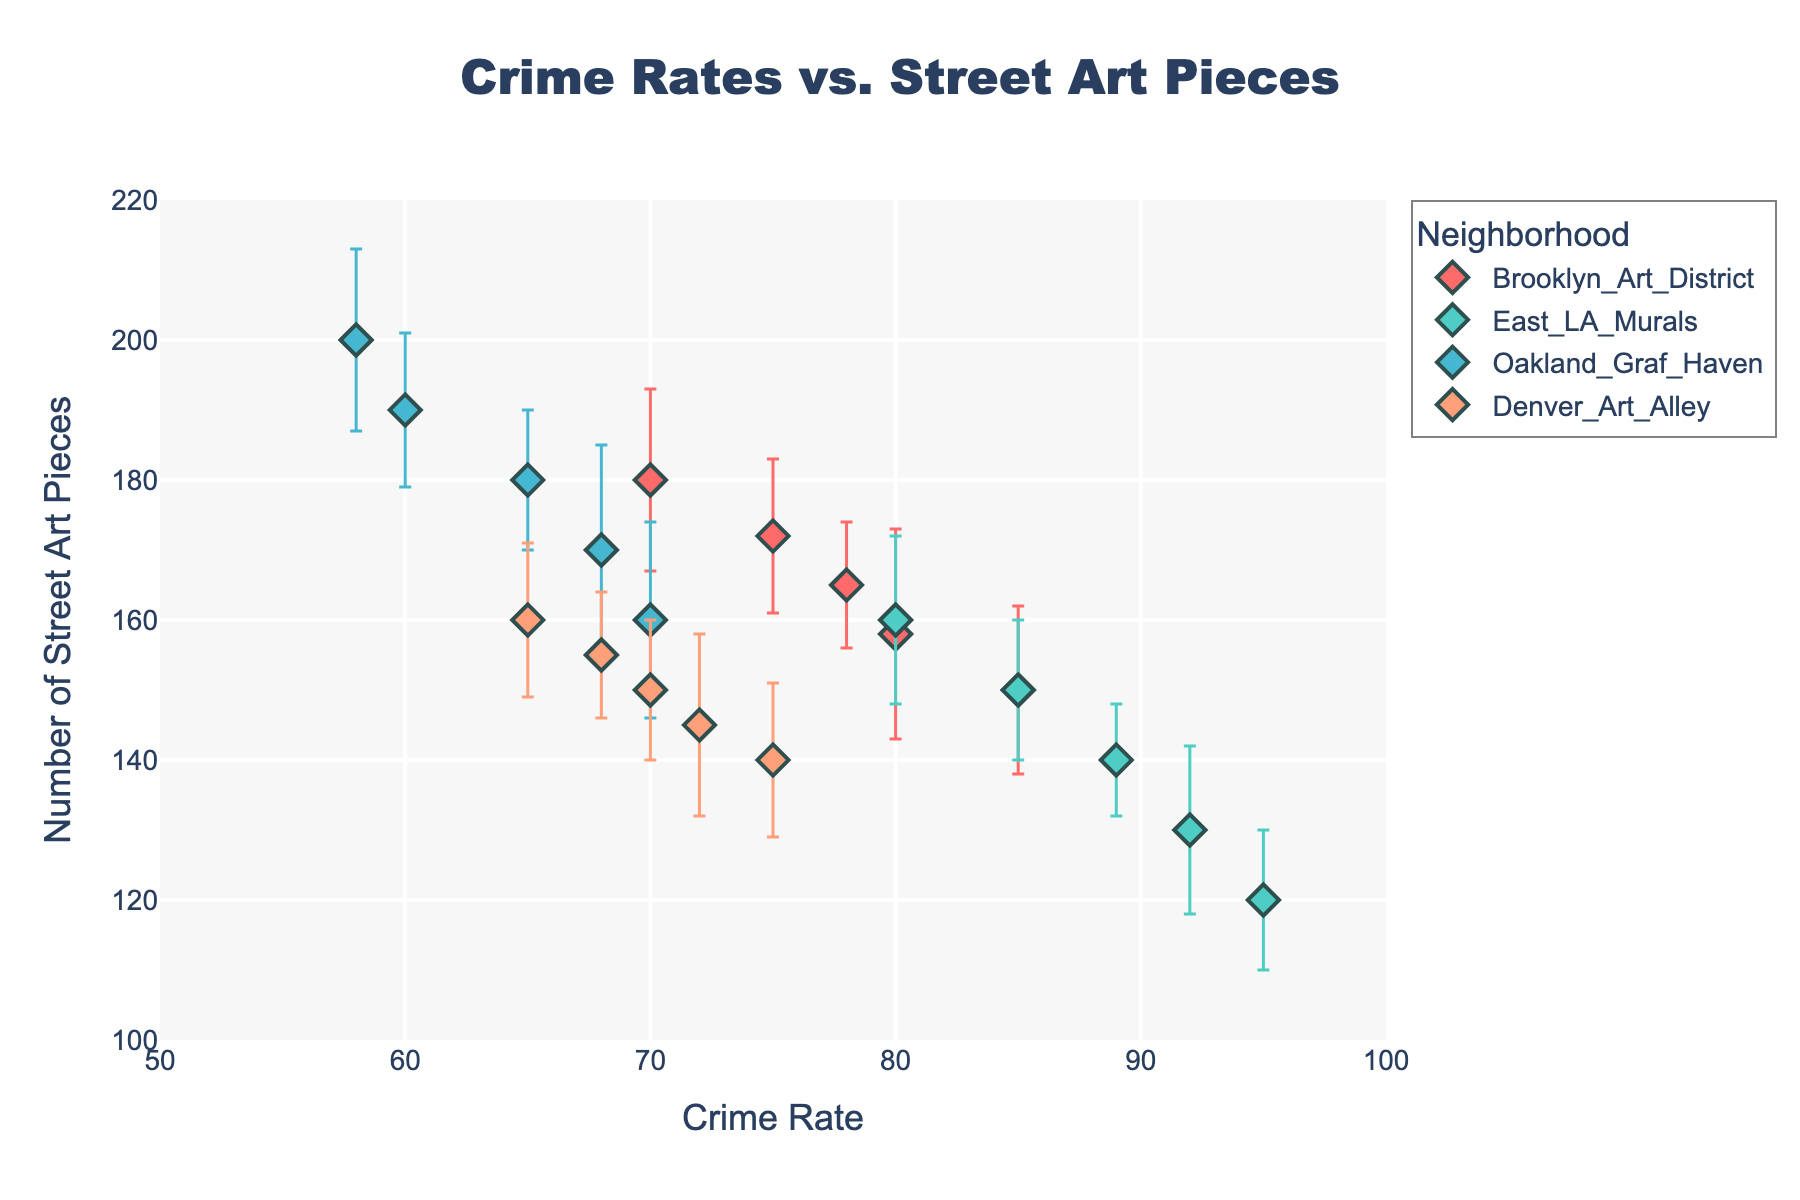What is the title of the scatter plot? The title is typically located at the top of the figure. In this case, it is "Crime Rates vs. Street Art Pieces".
Answer: Crime Rates vs. Street Art Pieces What are the axes labels in the scatter plot? The x-axis and y-axis labels provide information on what is being measured. The x-axis is labeled "Crime Rate" and the y-axis is labeled "Number of Street Art Pieces".
Answer: Crime Rate, Number of Street Art Pieces Which neighborhood has the highest number of street art pieces in 2022? By looking at the data points for 2022 across all neighborhoods, we focus on the y-axis values to see which one is the highest. Oakland_Graf_Haven has 200 street art pieces.
Answer: Oakland_Graf_Haven Among the neighborhoods, which one shows the steepest decrease in crime rate from 2018 to 2022? We need to inspect the numbers over time for each neighborhood and identify the one with the biggest drop. Brooklyn_Art_District drops from 85 to 70, a difference of 15. East_LA_Murals drops from 95 to 80, a difference of 15. Oakland_Graf_Haven drops from 70 to 58, a difference of 12. Denver_Art_Alley drops from 75 to 65, a difference of 10. Brooklyn_Art_District and East_LA_Murals show the steepest decrease.
Answer: Brooklyn_Art_District, East_LA_Murals What color represents Denver_Art_Alley in the scatter plot? Each neighborhood is represented by a unique color. Denver_Art_Alley is mentioned last in the code and corresponds to the color 'orange'.
Answer: orange How does the number of street art pieces in Brooklyn_Art_District change from 2018 to 2022? By tracking the values for Brooklyn_Art_District over these years: 150, 158, 165, 172, 180, we see a consistent increase.
Answer: Increase Which neighborhood has the largest variability in the number of street art pieces in any given year? Variability is shown by the length of the error bars. We evaluate the error bar sizes across all neighborhoods and years. Brooklyn_Art_District shows standard deviations of 12, 15, 9, 11, and 13. East_LA_Murals shows 10, 12, 8, 10, and 12. Oakland_Graf_Haven shows 14, 15, 10, 11, and 13. Denver_Art_Alley shows 11, 13, 10, 9, 11. Oakland_Graf_Haven has the largest error bar of 15.
Answer: Oakland_Graf_Haven Which neighborhood has the least crime rate in 2022? Focus on the data points marked for 2022, we find that Oakland_Graf_Haven has a crime rate of 58, which is the lowest.
Answer: Oakland_Graf_Haven Is there a general trend between crime rates and the number of street art pieces? By examining the scatter plot as a whole, we can notice any general trend or correlation. Generally, as the number of street art pieces increases, the crime rate tends to decrease.
Answer: As street art pieces increase, crime rates decrease Which neighborhood's crime rate is closest to the average crime rate of all neighborhoods in 2020? First, calculate the average crime rate in 2020: (78+89+65+70) / 4 = 75.5. Then compare individual neighborhood rates to this average. Denver_Art_Alley at 70 is closest to 75.5.
Answer: Denver_Art_Alley 